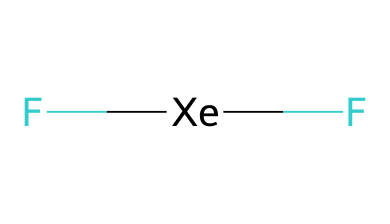what is the central atom in xenon difluoride? The chemical structure includes two fluorine atoms bonded to one xenon atom, making xenon the central atom.
Answer: xenon how many bonds are present in xenon difluoride? The structure has two bonds, as each fluorine atom forms a single bond with the xenon atom.
Answer: 2 what type of bonding occurs between xenon and fluorine in xenon difluoride? The bonds between xenon and fluorine are covalent bonds, as electrons are shared between xenon and each fluorine atom.
Answer: covalent is xenon difluoride a hypervalent compound? Yes, xenon difluoride is considered a hypervalent compound because the xenon atom can accommodate more than four electron pairs due to its expanded octet.
Answer: yes what is the molecular geometry of xenon difluoride? The molecular geometry of xenon difluoride is linear, which arises from the arrangement of the two fluorine atoms around the central xenon atom, minimizing electron pair repulsion.
Answer: linear how many total valence electrons are used in xenon difluoride? The total number of valence electrons is 10, calculated by adding the 8 from xenon and 2 from the two fluorine atoms (each contributing 1).
Answer: 10 what role does xenon difluoride play in spacecraft propulsion systems? Xenon difluoride is used as a propellant in certain types of spacecraft propulsion systems, taking advantage of its chemical properties.
Answer: propellant 